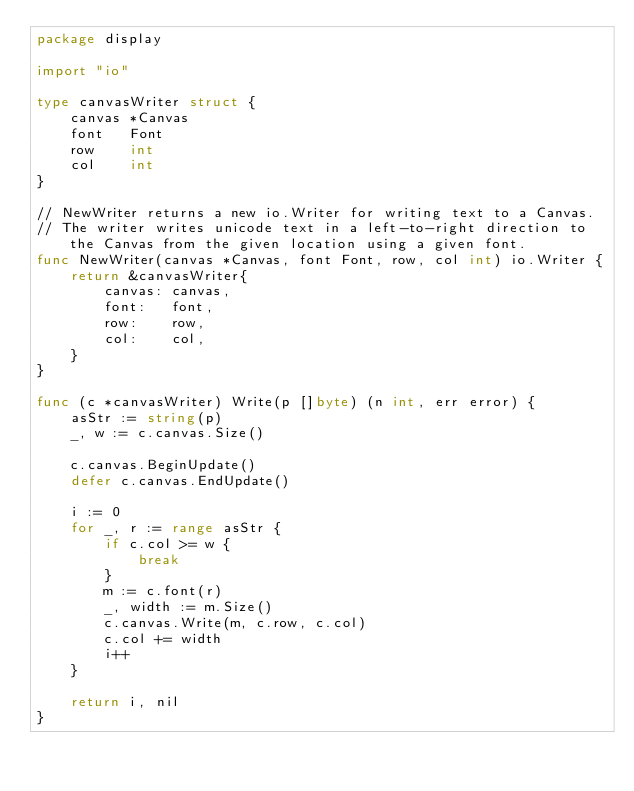Convert code to text. <code><loc_0><loc_0><loc_500><loc_500><_Go_>package display

import "io"

type canvasWriter struct {
	canvas *Canvas
	font   Font
	row    int
	col    int
}

// NewWriter returns a new io.Writer for writing text to a Canvas.
// The writer writes unicode text in a left-to-right direction to the Canvas from the given location using a given font.
func NewWriter(canvas *Canvas, font Font, row, col int) io.Writer {
	return &canvasWriter{
		canvas: canvas,
		font:   font,
		row:    row,
		col:    col,
	}
}

func (c *canvasWriter) Write(p []byte) (n int, err error) {
	asStr := string(p)
	_, w := c.canvas.Size()

	c.canvas.BeginUpdate()
	defer c.canvas.EndUpdate()

	i := 0
	for _, r := range asStr {
		if c.col >= w {
			break
		}
		m := c.font(r)
		_, width := m.Size()
		c.canvas.Write(m, c.row, c.col)
		c.col += width
		i++
	}

	return i, nil
}
</code> 